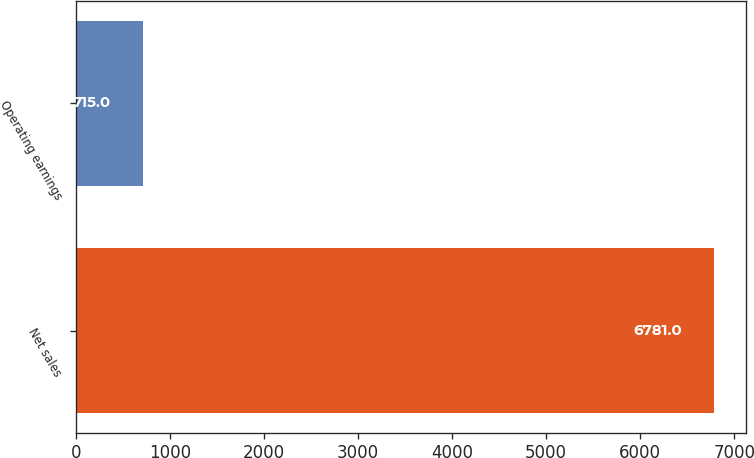Convert chart. <chart><loc_0><loc_0><loc_500><loc_500><bar_chart><fcel>Net sales<fcel>Operating earnings<nl><fcel>6781<fcel>715<nl></chart> 